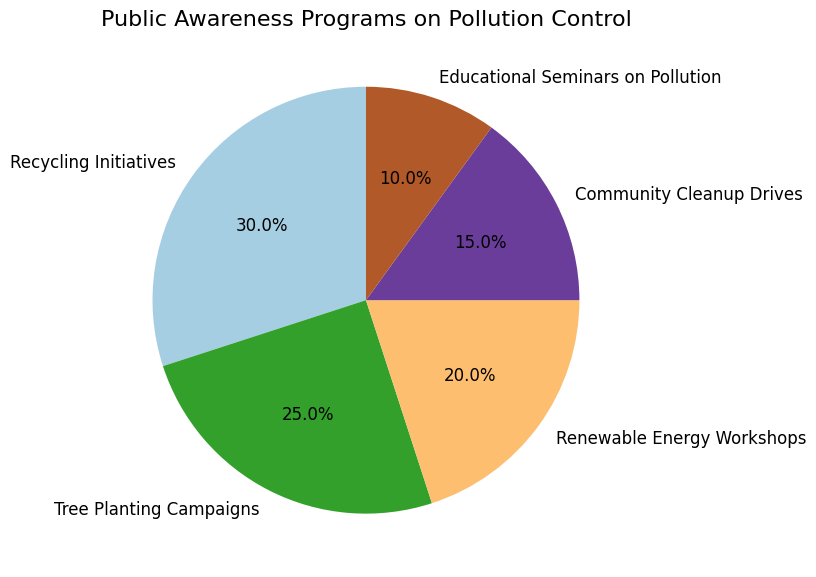What percentage of public awareness programs are focused on tree planting campaigns? To find the percentage for the "Tree Planting Campaigns", we look at the pie chart section labeled "Tree Planting Campaigns". It is labeled with its percentage share.
Answer: 25% Which awareness program has the smallest share, and what is its percentage? To identify the smallest share, we look for the smallest section of the pie chart and read its label and percentage.
Answer: Educational Seminars on Pollution, 10% What is the total percentage of initiatives related to physical activities (Recycling Initiatives, Tree Planting Campaigns, and Community Cleanup Drives)? Sum the percentages of the programs involving physical activities: Recycling Initiatives (30%) + Tree Planting Campaigns (25%) + Community Cleanup Drives (15%).
Answer: 70% Which two programs have the most similar percentages? Compare the percentages for each pair of programs to find the pair with the smallest difference. The closest values are Tree Planting Campaigns (25%) and Renewable Energy Workshops (20%), with a 5% difference.
Answer: Tree Planting Campaigns and Renewable Energy Workshops How much greater is the percentage for Renewable Energy Workshops compared to Educational Seminars on Pollution? Subtract the percentage of Educational Seminars on Pollution (10%) from the percentage of Renewable Energy Workshops (20%).
Answer: 10% If the percentage of Tree Planting Campaigns increased by 5%, what would its new percentage be, and how would that affect its ranking among other initiatives? Add 5% to the current percentage of Tree Planting Campaigns (25% + 5% = 30%). It would then be tied with Recycling Initiatives for the highest percentage.
Answer: 30%, tied for highest Which program has the most significant visual area on the pie chart, and what visual technique helps identify it? The largest area visually represents the program with the highest percentage. Recycling Initiatives (30%) occupies the largest area, made more identifiable by segment size.
Answer: Recycling Initiatives, segment size How do the combined percentages of Renewable Energy Workshops and Community Cleanup Drives compare to Recycling Initiatives? Add the percentages for Renewable Energy Workshops (20%) and Community Cleanup Drives (15%) and compare the sum to Recycling Initiatives (30%). 20% + 15% = 35%, which is greater than 30%.
Answer: 35% is greater than 30% If we had to consolidate all programs with less than 20% into a single category, what percentage would that new category represent? Sum the percentages of programs with less than 20%: Community Cleanup Drives (15%) + Educational Seminars on Pollution (10%).
Answer: 25% 